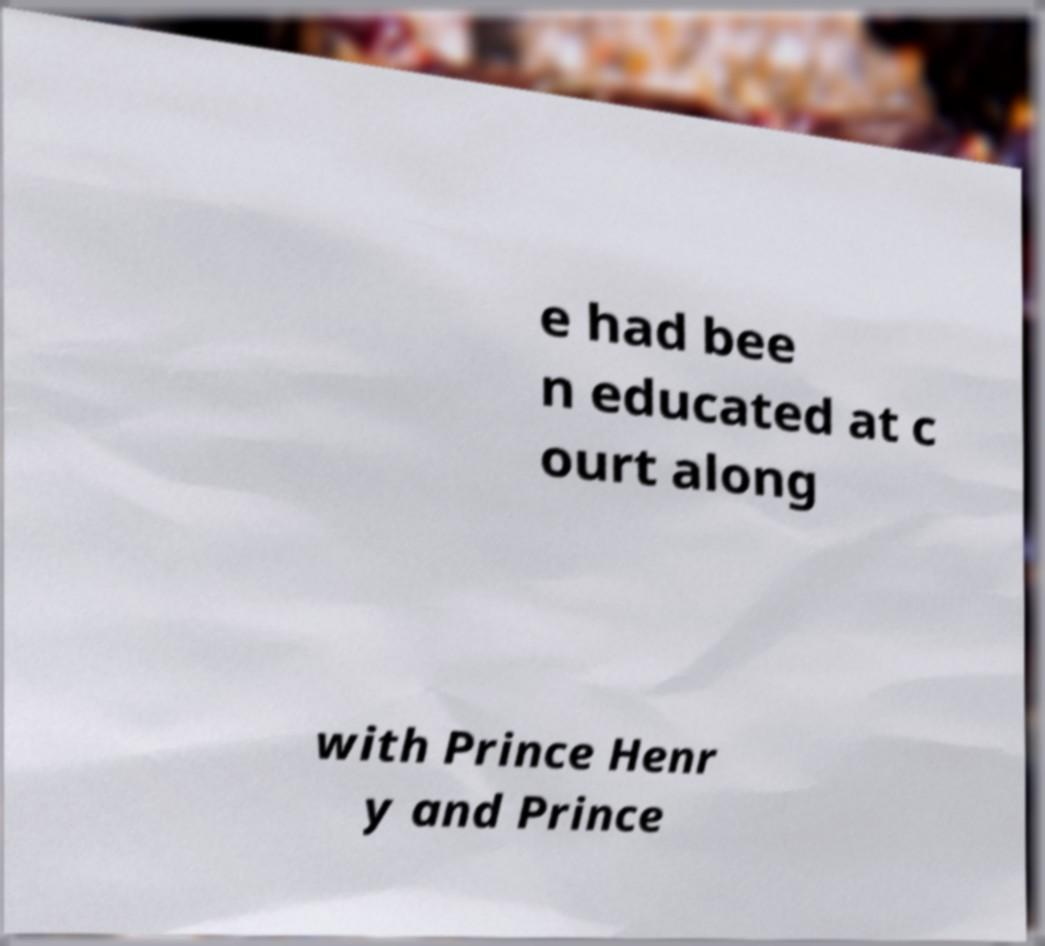Could you extract and type out the text from this image? e had bee n educated at c ourt along with Prince Henr y and Prince 